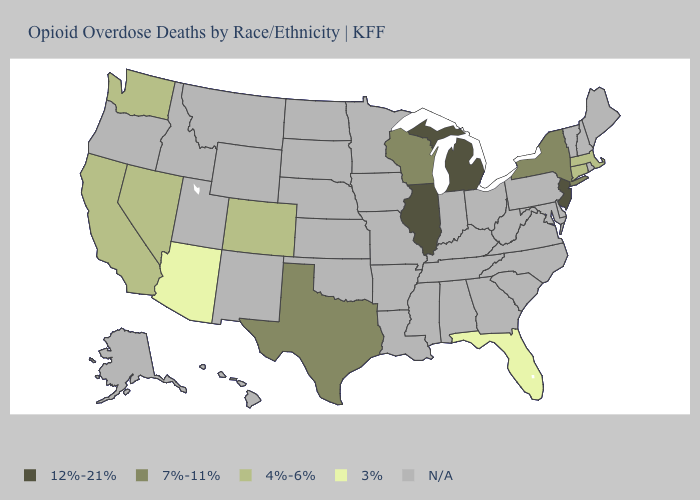Which states have the lowest value in the South?
Quick response, please. Florida. Does Wisconsin have the lowest value in the MidWest?
Short answer required. Yes. What is the value of Colorado?
Answer briefly. 4%-6%. Name the states that have a value in the range N/A?
Concise answer only. Alabama, Alaska, Arkansas, Delaware, Georgia, Hawaii, Idaho, Indiana, Iowa, Kansas, Kentucky, Louisiana, Maine, Maryland, Minnesota, Mississippi, Missouri, Montana, Nebraska, New Hampshire, New Mexico, North Carolina, North Dakota, Ohio, Oklahoma, Oregon, Pennsylvania, Rhode Island, South Carolina, South Dakota, Tennessee, Utah, Vermont, Virginia, West Virginia, Wyoming. What is the lowest value in the USA?
Be succinct. 3%. What is the lowest value in the MidWest?
Keep it brief. 7%-11%. What is the value of Colorado?
Be succinct. 4%-6%. What is the value of Wisconsin?
Concise answer only. 7%-11%. What is the highest value in the South ?
Give a very brief answer. 7%-11%. What is the value of New York?
Keep it brief. 7%-11%. What is the lowest value in the USA?
Keep it brief. 3%. What is the value of Indiana?
Give a very brief answer. N/A. What is the value of Nebraska?
Answer briefly. N/A. 